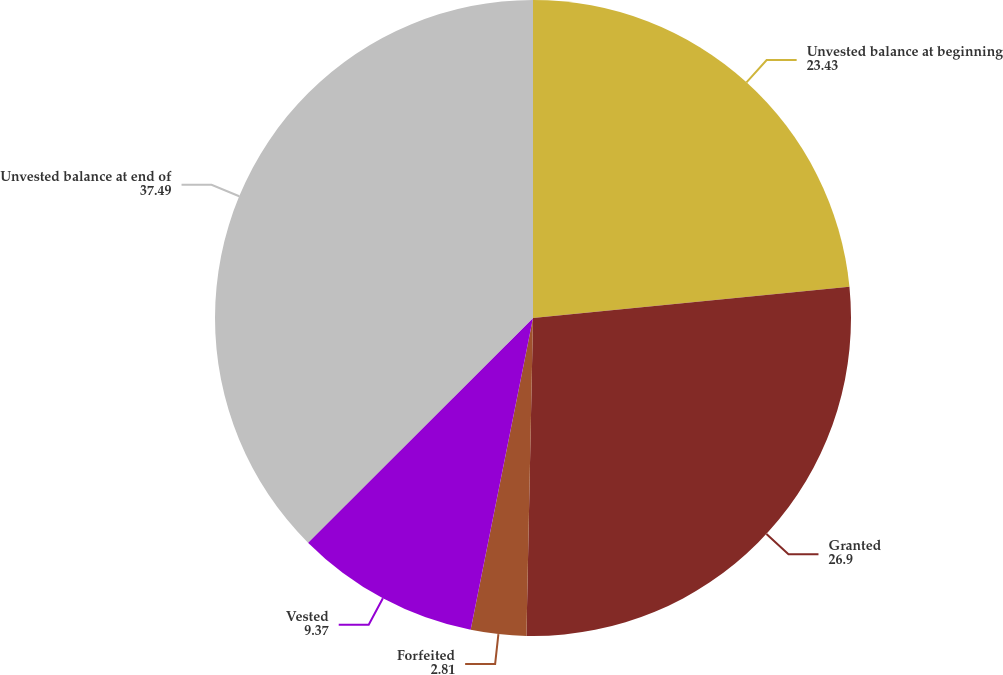<chart> <loc_0><loc_0><loc_500><loc_500><pie_chart><fcel>Unvested balance at beginning<fcel>Granted<fcel>Forfeited<fcel>Vested<fcel>Unvested balance at end of<nl><fcel>23.43%<fcel>26.9%<fcel>2.81%<fcel>9.37%<fcel>37.49%<nl></chart> 